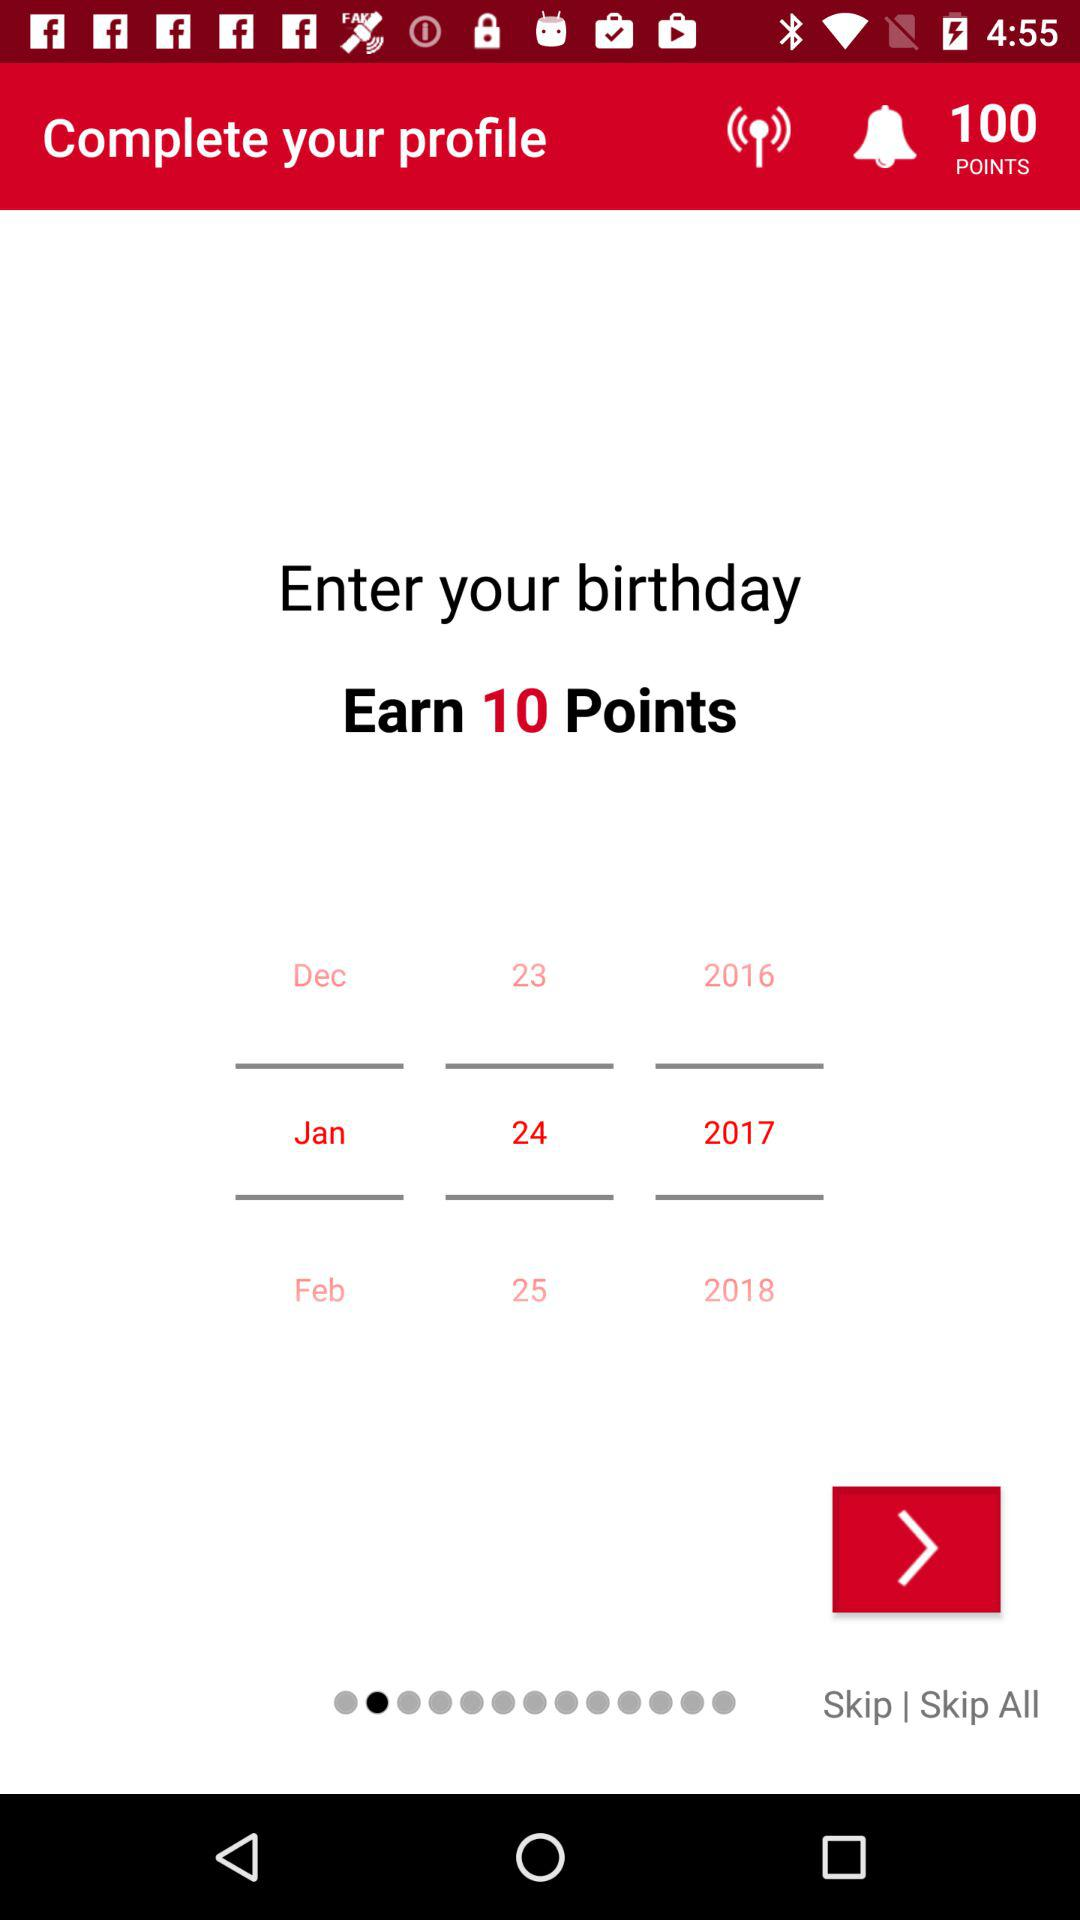How many years are available to select from?
Answer the question using a single word or phrase. 3 